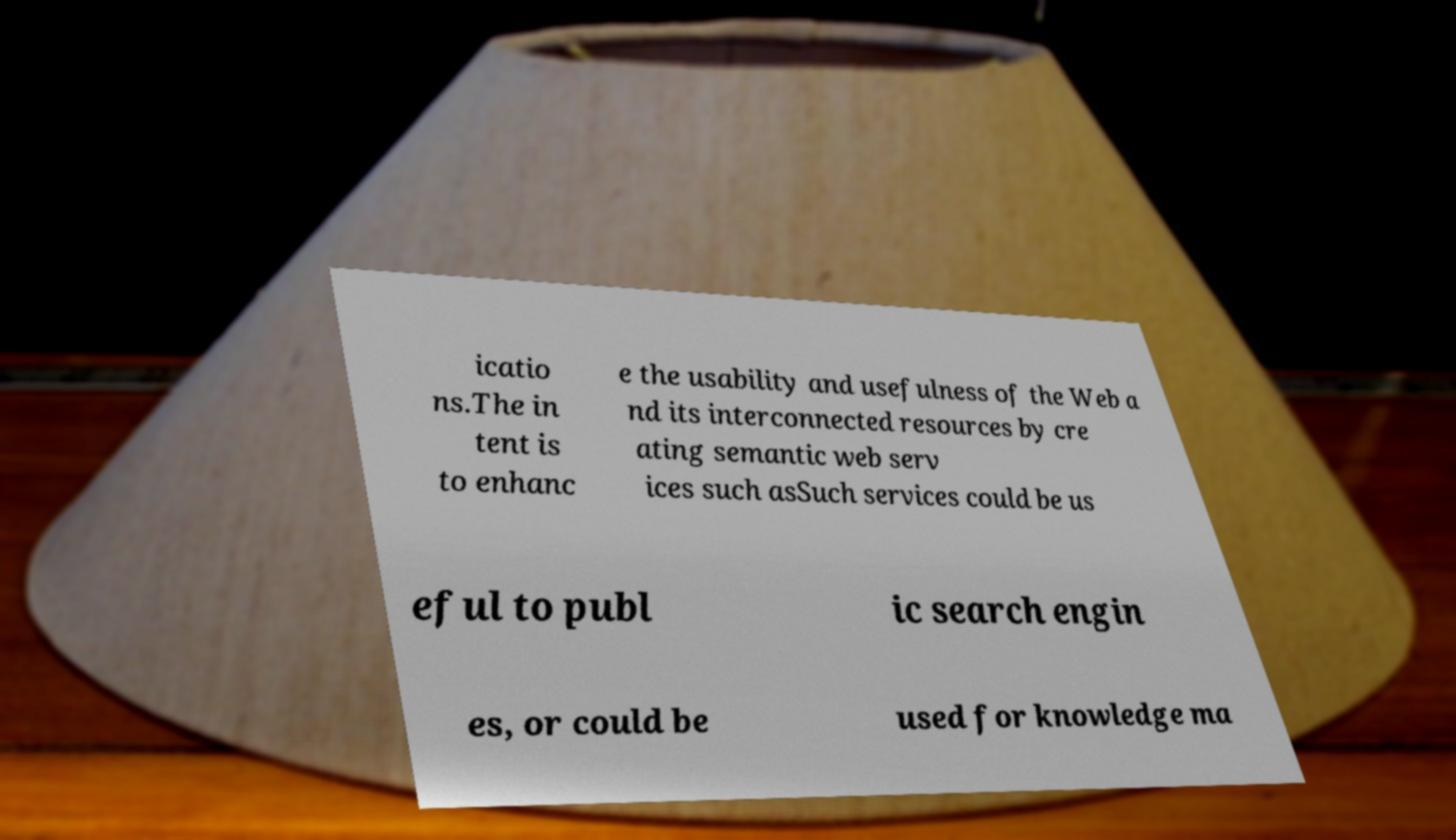Please identify and transcribe the text found in this image. icatio ns.The in tent is to enhanc e the usability and usefulness of the Web a nd its interconnected resources by cre ating semantic web serv ices such asSuch services could be us eful to publ ic search engin es, or could be used for knowledge ma 